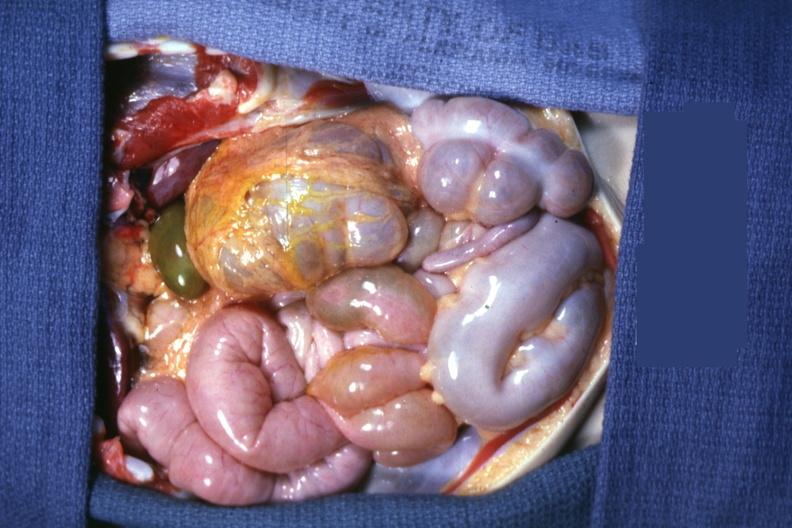does this image show opened peritoneal cavity showing cecum and appendix on left side?
Answer the question using a single word or phrase. Yes 